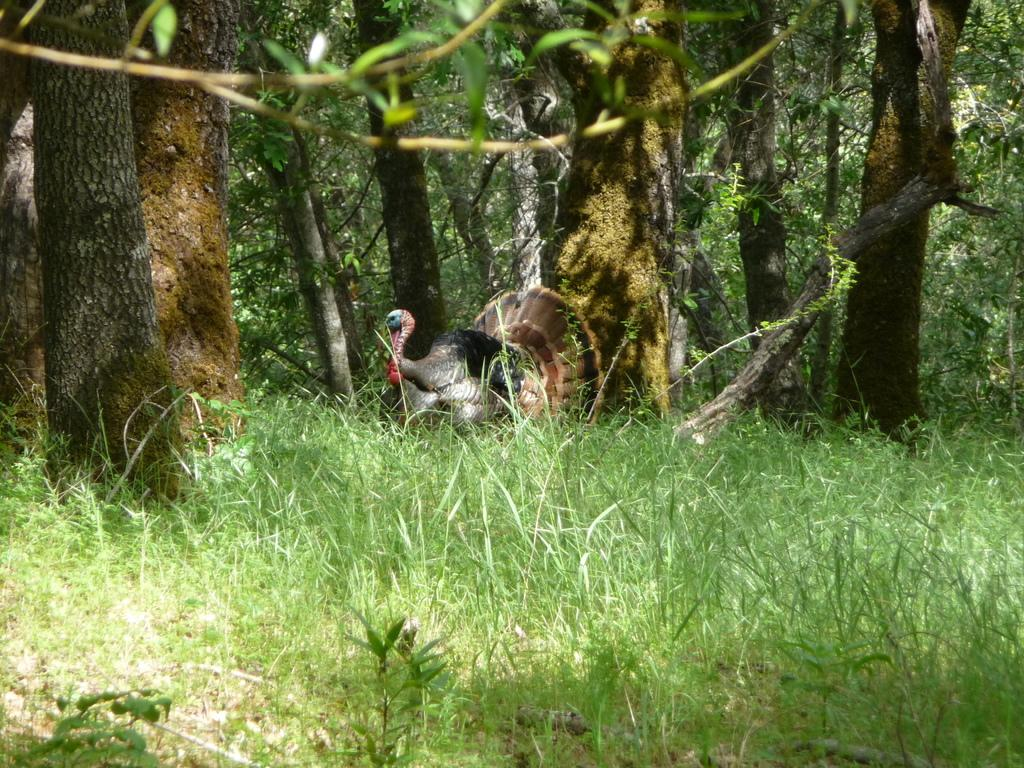What type of vegetation is present on the ground in the image? There are plants and grass on the ground in the image. What can be seen in the background of the image? In the background, there is a peacock and trees on the ground. What type of fruit is being held by the vein in the image? There is no fruit or vein present in the image. What type of drink is being consumed by the peacock in the image? There is no drink being consumed by the peacock in the image. 